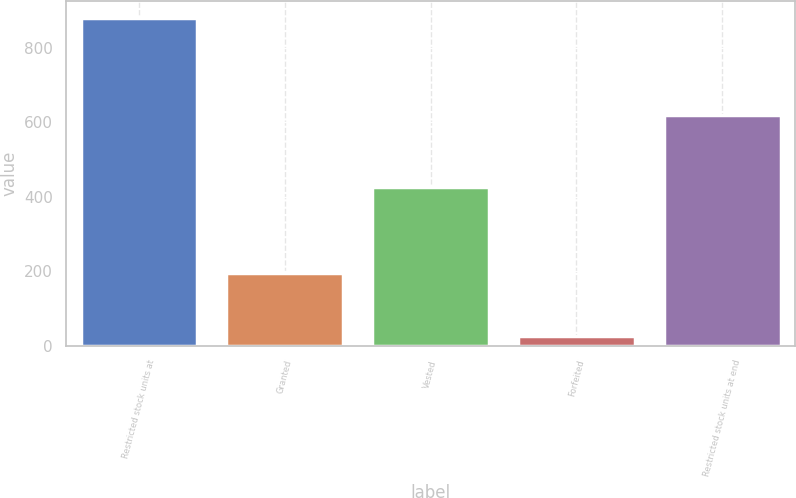Convert chart. <chart><loc_0><loc_0><loc_500><loc_500><bar_chart><fcel>Restricted stock units at<fcel>Granted<fcel>Vested<fcel>Forfeited<fcel>Restricted stock units at end<nl><fcel>880<fcel>195<fcel>427<fcel>28<fcel>620<nl></chart> 